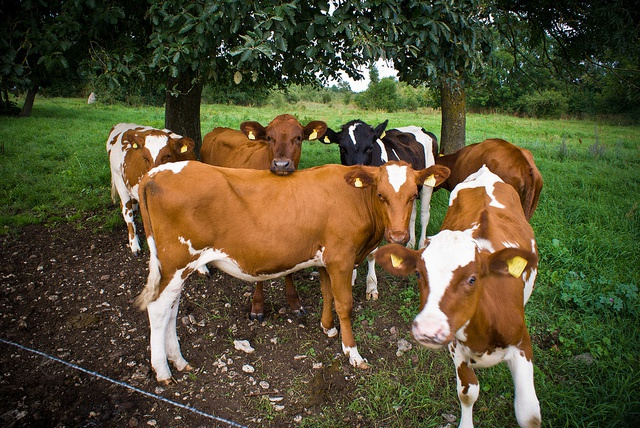Describe the objects in this image and their specific colors. I can see cow in black, brown, orange, lightgray, and maroon tones, cow in black, brown, white, and maroon tones, cow in black, brown, and maroon tones, cow in black, lightgray, brown, and maroon tones, and cow in black, lightgray, maroon, and darkgray tones in this image. 